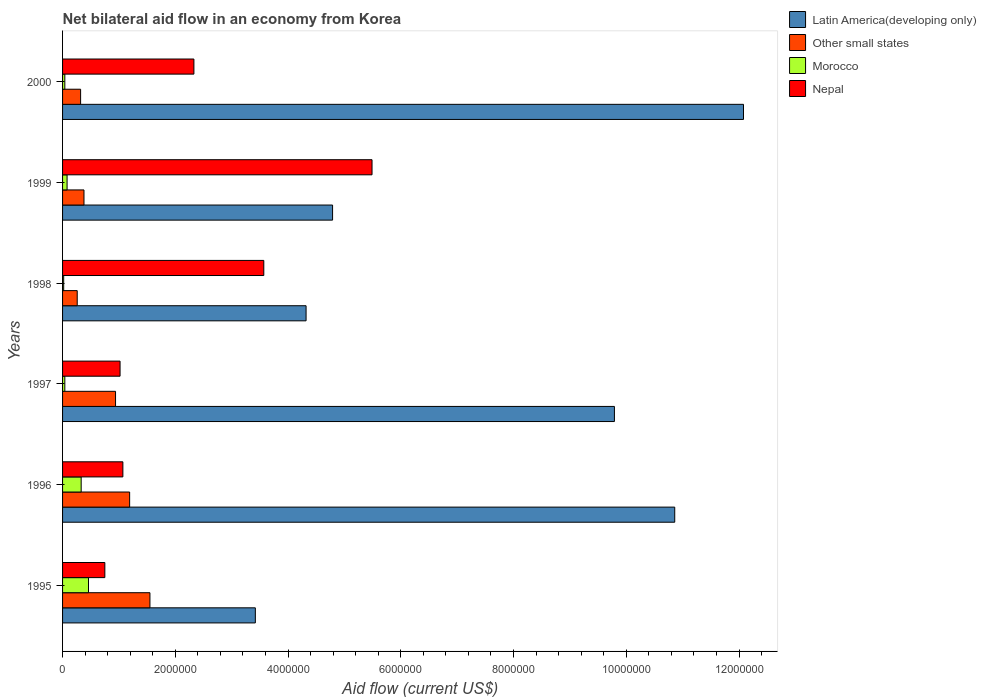Are the number of bars per tick equal to the number of legend labels?
Your answer should be very brief. Yes. How many bars are there on the 3rd tick from the top?
Provide a short and direct response. 4. What is the label of the 2nd group of bars from the top?
Your answer should be very brief. 1999. What is the net bilateral aid flow in Morocco in 1996?
Ensure brevity in your answer.  3.30e+05. Across all years, what is the maximum net bilateral aid flow in Nepal?
Give a very brief answer. 5.49e+06. Across all years, what is the minimum net bilateral aid flow in Other small states?
Your response must be concise. 2.60e+05. In which year was the net bilateral aid flow in Morocco maximum?
Ensure brevity in your answer.  1995. What is the total net bilateral aid flow in Nepal in the graph?
Make the answer very short. 1.42e+07. What is the difference between the net bilateral aid flow in Nepal in 1997 and that in 1999?
Offer a very short reply. -4.47e+06. What is the difference between the net bilateral aid flow in Latin America(developing only) in 1996 and the net bilateral aid flow in Morocco in 1995?
Your answer should be very brief. 1.04e+07. What is the average net bilateral aid flow in Nepal per year?
Keep it short and to the point. 2.37e+06. In the year 1995, what is the difference between the net bilateral aid flow in Morocco and net bilateral aid flow in Other small states?
Provide a short and direct response. -1.09e+06. In how many years, is the net bilateral aid flow in Morocco greater than 800000 US$?
Offer a terse response. 0. Is the net bilateral aid flow in Nepal in 1996 less than that in 1998?
Give a very brief answer. Yes. What is the difference between the highest and the second highest net bilateral aid flow in Latin America(developing only)?
Offer a very short reply. 1.22e+06. What is the difference between the highest and the lowest net bilateral aid flow in Nepal?
Make the answer very short. 4.74e+06. In how many years, is the net bilateral aid flow in Other small states greater than the average net bilateral aid flow in Other small states taken over all years?
Give a very brief answer. 3. What does the 3rd bar from the top in 1999 represents?
Provide a short and direct response. Other small states. What does the 1st bar from the bottom in 1999 represents?
Your answer should be very brief. Latin America(developing only). How many years are there in the graph?
Your answer should be compact. 6. What is the difference between two consecutive major ticks on the X-axis?
Your response must be concise. 2.00e+06. What is the title of the graph?
Give a very brief answer. Net bilateral aid flow in an economy from Korea. Does "Tonga" appear as one of the legend labels in the graph?
Make the answer very short. No. What is the Aid flow (current US$) in Latin America(developing only) in 1995?
Your response must be concise. 3.42e+06. What is the Aid flow (current US$) of Other small states in 1995?
Give a very brief answer. 1.55e+06. What is the Aid flow (current US$) of Nepal in 1995?
Offer a very short reply. 7.50e+05. What is the Aid flow (current US$) in Latin America(developing only) in 1996?
Keep it short and to the point. 1.09e+07. What is the Aid flow (current US$) in Other small states in 1996?
Provide a short and direct response. 1.19e+06. What is the Aid flow (current US$) of Morocco in 1996?
Offer a terse response. 3.30e+05. What is the Aid flow (current US$) of Nepal in 1996?
Keep it short and to the point. 1.07e+06. What is the Aid flow (current US$) of Latin America(developing only) in 1997?
Your response must be concise. 9.79e+06. What is the Aid flow (current US$) of Other small states in 1997?
Provide a short and direct response. 9.40e+05. What is the Aid flow (current US$) in Morocco in 1997?
Your answer should be very brief. 4.00e+04. What is the Aid flow (current US$) in Nepal in 1997?
Ensure brevity in your answer.  1.02e+06. What is the Aid flow (current US$) in Latin America(developing only) in 1998?
Your response must be concise. 4.32e+06. What is the Aid flow (current US$) of Nepal in 1998?
Your answer should be compact. 3.57e+06. What is the Aid flow (current US$) of Latin America(developing only) in 1999?
Your answer should be very brief. 4.79e+06. What is the Aid flow (current US$) in Other small states in 1999?
Give a very brief answer. 3.80e+05. What is the Aid flow (current US$) of Morocco in 1999?
Offer a very short reply. 8.00e+04. What is the Aid flow (current US$) in Nepal in 1999?
Provide a short and direct response. 5.49e+06. What is the Aid flow (current US$) in Latin America(developing only) in 2000?
Provide a succinct answer. 1.21e+07. What is the Aid flow (current US$) in Morocco in 2000?
Your answer should be compact. 4.00e+04. What is the Aid flow (current US$) of Nepal in 2000?
Your answer should be very brief. 2.33e+06. Across all years, what is the maximum Aid flow (current US$) in Latin America(developing only)?
Your answer should be very brief. 1.21e+07. Across all years, what is the maximum Aid flow (current US$) in Other small states?
Make the answer very short. 1.55e+06. Across all years, what is the maximum Aid flow (current US$) in Morocco?
Your answer should be compact. 4.60e+05. Across all years, what is the maximum Aid flow (current US$) in Nepal?
Keep it short and to the point. 5.49e+06. Across all years, what is the minimum Aid flow (current US$) in Latin America(developing only)?
Offer a very short reply. 3.42e+06. Across all years, what is the minimum Aid flow (current US$) in Morocco?
Offer a very short reply. 2.00e+04. Across all years, what is the minimum Aid flow (current US$) of Nepal?
Ensure brevity in your answer.  7.50e+05. What is the total Aid flow (current US$) in Latin America(developing only) in the graph?
Offer a very short reply. 4.53e+07. What is the total Aid flow (current US$) of Other small states in the graph?
Provide a short and direct response. 4.64e+06. What is the total Aid flow (current US$) in Morocco in the graph?
Your answer should be very brief. 9.70e+05. What is the total Aid flow (current US$) in Nepal in the graph?
Keep it short and to the point. 1.42e+07. What is the difference between the Aid flow (current US$) of Latin America(developing only) in 1995 and that in 1996?
Give a very brief answer. -7.44e+06. What is the difference between the Aid flow (current US$) in Other small states in 1995 and that in 1996?
Ensure brevity in your answer.  3.60e+05. What is the difference between the Aid flow (current US$) in Morocco in 1995 and that in 1996?
Keep it short and to the point. 1.30e+05. What is the difference between the Aid flow (current US$) of Nepal in 1995 and that in 1996?
Offer a terse response. -3.20e+05. What is the difference between the Aid flow (current US$) of Latin America(developing only) in 1995 and that in 1997?
Your response must be concise. -6.37e+06. What is the difference between the Aid flow (current US$) of Other small states in 1995 and that in 1997?
Give a very brief answer. 6.10e+05. What is the difference between the Aid flow (current US$) in Nepal in 1995 and that in 1997?
Offer a very short reply. -2.70e+05. What is the difference between the Aid flow (current US$) in Latin America(developing only) in 1995 and that in 1998?
Your answer should be compact. -9.00e+05. What is the difference between the Aid flow (current US$) of Other small states in 1995 and that in 1998?
Keep it short and to the point. 1.29e+06. What is the difference between the Aid flow (current US$) in Morocco in 1995 and that in 1998?
Your answer should be very brief. 4.40e+05. What is the difference between the Aid flow (current US$) in Nepal in 1995 and that in 1998?
Your response must be concise. -2.82e+06. What is the difference between the Aid flow (current US$) of Latin America(developing only) in 1995 and that in 1999?
Your answer should be very brief. -1.37e+06. What is the difference between the Aid flow (current US$) in Other small states in 1995 and that in 1999?
Ensure brevity in your answer.  1.17e+06. What is the difference between the Aid flow (current US$) in Nepal in 1995 and that in 1999?
Your answer should be very brief. -4.74e+06. What is the difference between the Aid flow (current US$) in Latin America(developing only) in 1995 and that in 2000?
Ensure brevity in your answer.  -8.66e+06. What is the difference between the Aid flow (current US$) of Other small states in 1995 and that in 2000?
Your answer should be very brief. 1.23e+06. What is the difference between the Aid flow (current US$) in Morocco in 1995 and that in 2000?
Your answer should be very brief. 4.20e+05. What is the difference between the Aid flow (current US$) of Nepal in 1995 and that in 2000?
Your answer should be compact. -1.58e+06. What is the difference between the Aid flow (current US$) of Latin America(developing only) in 1996 and that in 1997?
Make the answer very short. 1.07e+06. What is the difference between the Aid flow (current US$) of Other small states in 1996 and that in 1997?
Offer a terse response. 2.50e+05. What is the difference between the Aid flow (current US$) of Latin America(developing only) in 1996 and that in 1998?
Offer a very short reply. 6.54e+06. What is the difference between the Aid flow (current US$) in Other small states in 1996 and that in 1998?
Provide a succinct answer. 9.30e+05. What is the difference between the Aid flow (current US$) in Nepal in 1996 and that in 1998?
Your answer should be compact. -2.50e+06. What is the difference between the Aid flow (current US$) in Latin America(developing only) in 1996 and that in 1999?
Your answer should be very brief. 6.07e+06. What is the difference between the Aid flow (current US$) of Other small states in 1996 and that in 1999?
Provide a succinct answer. 8.10e+05. What is the difference between the Aid flow (current US$) in Nepal in 1996 and that in 1999?
Your answer should be compact. -4.42e+06. What is the difference between the Aid flow (current US$) in Latin America(developing only) in 1996 and that in 2000?
Give a very brief answer. -1.22e+06. What is the difference between the Aid flow (current US$) of Other small states in 1996 and that in 2000?
Your answer should be compact. 8.70e+05. What is the difference between the Aid flow (current US$) in Morocco in 1996 and that in 2000?
Provide a succinct answer. 2.90e+05. What is the difference between the Aid flow (current US$) in Nepal in 1996 and that in 2000?
Provide a short and direct response. -1.26e+06. What is the difference between the Aid flow (current US$) in Latin America(developing only) in 1997 and that in 1998?
Your response must be concise. 5.47e+06. What is the difference between the Aid flow (current US$) of Other small states in 1997 and that in 1998?
Your answer should be compact. 6.80e+05. What is the difference between the Aid flow (current US$) in Nepal in 1997 and that in 1998?
Your answer should be very brief. -2.55e+06. What is the difference between the Aid flow (current US$) in Other small states in 1997 and that in 1999?
Offer a terse response. 5.60e+05. What is the difference between the Aid flow (current US$) of Nepal in 1997 and that in 1999?
Give a very brief answer. -4.47e+06. What is the difference between the Aid flow (current US$) in Latin America(developing only) in 1997 and that in 2000?
Provide a short and direct response. -2.29e+06. What is the difference between the Aid flow (current US$) of Other small states in 1997 and that in 2000?
Your answer should be compact. 6.20e+05. What is the difference between the Aid flow (current US$) in Nepal in 1997 and that in 2000?
Keep it short and to the point. -1.31e+06. What is the difference between the Aid flow (current US$) in Latin America(developing only) in 1998 and that in 1999?
Your response must be concise. -4.70e+05. What is the difference between the Aid flow (current US$) in Other small states in 1998 and that in 1999?
Your answer should be very brief. -1.20e+05. What is the difference between the Aid flow (current US$) of Morocco in 1998 and that in 1999?
Make the answer very short. -6.00e+04. What is the difference between the Aid flow (current US$) of Nepal in 1998 and that in 1999?
Give a very brief answer. -1.92e+06. What is the difference between the Aid flow (current US$) in Latin America(developing only) in 1998 and that in 2000?
Offer a terse response. -7.76e+06. What is the difference between the Aid flow (current US$) in Other small states in 1998 and that in 2000?
Your answer should be compact. -6.00e+04. What is the difference between the Aid flow (current US$) in Morocco in 1998 and that in 2000?
Keep it short and to the point. -2.00e+04. What is the difference between the Aid flow (current US$) in Nepal in 1998 and that in 2000?
Your answer should be very brief. 1.24e+06. What is the difference between the Aid flow (current US$) in Latin America(developing only) in 1999 and that in 2000?
Offer a terse response. -7.29e+06. What is the difference between the Aid flow (current US$) in Other small states in 1999 and that in 2000?
Give a very brief answer. 6.00e+04. What is the difference between the Aid flow (current US$) of Nepal in 1999 and that in 2000?
Offer a terse response. 3.16e+06. What is the difference between the Aid flow (current US$) in Latin America(developing only) in 1995 and the Aid flow (current US$) in Other small states in 1996?
Provide a short and direct response. 2.23e+06. What is the difference between the Aid flow (current US$) of Latin America(developing only) in 1995 and the Aid flow (current US$) of Morocco in 1996?
Ensure brevity in your answer.  3.09e+06. What is the difference between the Aid flow (current US$) of Latin America(developing only) in 1995 and the Aid flow (current US$) of Nepal in 1996?
Your answer should be very brief. 2.35e+06. What is the difference between the Aid flow (current US$) in Other small states in 1995 and the Aid flow (current US$) in Morocco in 1996?
Make the answer very short. 1.22e+06. What is the difference between the Aid flow (current US$) of Morocco in 1995 and the Aid flow (current US$) of Nepal in 1996?
Give a very brief answer. -6.10e+05. What is the difference between the Aid flow (current US$) in Latin America(developing only) in 1995 and the Aid flow (current US$) in Other small states in 1997?
Provide a short and direct response. 2.48e+06. What is the difference between the Aid flow (current US$) in Latin America(developing only) in 1995 and the Aid flow (current US$) in Morocco in 1997?
Offer a very short reply. 3.38e+06. What is the difference between the Aid flow (current US$) in Latin America(developing only) in 1995 and the Aid flow (current US$) in Nepal in 1997?
Offer a terse response. 2.40e+06. What is the difference between the Aid flow (current US$) of Other small states in 1995 and the Aid flow (current US$) of Morocco in 1997?
Your answer should be very brief. 1.51e+06. What is the difference between the Aid flow (current US$) of Other small states in 1995 and the Aid flow (current US$) of Nepal in 1997?
Offer a very short reply. 5.30e+05. What is the difference between the Aid flow (current US$) of Morocco in 1995 and the Aid flow (current US$) of Nepal in 1997?
Provide a succinct answer. -5.60e+05. What is the difference between the Aid flow (current US$) of Latin America(developing only) in 1995 and the Aid flow (current US$) of Other small states in 1998?
Provide a succinct answer. 3.16e+06. What is the difference between the Aid flow (current US$) in Latin America(developing only) in 1995 and the Aid flow (current US$) in Morocco in 1998?
Offer a terse response. 3.40e+06. What is the difference between the Aid flow (current US$) in Other small states in 1995 and the Aid flow (current US$) in Morocco in 1998?
Make the answer very short. 1.53e+06. What is the difference between the Aid flow (current US$) of Other small states in 1995 and the Aid flow (current US$) of Nepal in 1998?
Make the answer very short. -2.02e+06. What is the difference between the Aid flow (current US$) in Morocco in 1995 and the Aid flow (current US$) in Nepal in 1998?
Give a very brief answer. -3.11e+06. What is the difference between the Aid flow (current US$) in Latin America(developing only) in 1995 and the Aid flow (current US$) in Other small states in 1999?
Give a very brief answer. 3.04e+06. What is the difference between the Aid flow (current US$) of Latin America(developing only) in 1995 and the Aid flow (current US$) of Morocco in 1999?
Provide a short and direct response. 3.34e+06. What is the difference between the Aid flow (current US$) of Latin America(developing only) in 1995 and the Aid flow (current US$) of Nepal in 1999?
Make the answer very short. -2.07e+06. What is the difference between the Aid flow (current US$) of Other small states in 1995 and the Aid flow (current US$) of Morocco in 1999?
Provide a succinct answer. 1.47e+06. What is the difference between the Aid flow (current US$) of Other small states in 1995 and the Aid flow (current US$) of Nepal in 1999?
Offer a terse response. -3.94e+06. What is the difference between the Aid flow (current US$) in Morocco in 1995 and the Aid flow (current US$) in Nepal in 1999?
Ensure brevity in your answer.  -5.03e+06. What is the difference between the Aid flow (current US$) of Latin America(developing only) in 1995 and the Aid flow (current US$) of Other small states in 2000?
Ensure brevity in your answer.  3.10e+06. What is the difference between the Aid flow (current US$) in Latin America(developing only) in 1995 and the Aid flow (current US$) in Morocco in 2000?
Ensure brevity in your answer.  3.38e+06. What is the difference between the Aid flow (current US$) in Latin America(developing only) in 1995 and the Aid flow (current US$) in Nepal in 2000?
Your answer should be very brief. 1.09e+06. What is the difference between the Aid flow (current US$) of Other small states in 1995 and the Aid flow (current US$) of Morocco in 2000?
Keep it short and to the point. 1.51e+06. What is the difference between the Aid flow (current US$) of Other small states in 1995 and the Aid flow (current US$) of Nepal in 2000?
Your response must be concise. -7.80e+05. What is the difference between the Aid flow (current US$) in Morocco in 1995 and the Aid flow (current US$) in Nepal in 2000?
Your answer should be very brief. -1.87e+06. What is the difference between the Aid flow (current US$) in Latin America(developing only) in 1996 and the Aid flow (current US$) in Other small states in 1997?
Offer a very short reply. 9.92e+06. What is the difference between the Aid flow (current US$) of Latin America(developing only) in 1996 and the Aid flow (current US$) of Morocco in 1997?
Your answer should be very brief. 1.08e+07. What is the difference between the Aid flow (current US$) in Latin America(developing only) in 1996 and the Aid flow (current US$) in Nepal in 1997?
Ensure brevity in your answer.  9.84e+06. What is the difference between the Aid flow (current US$) in Other small states in 1996 and the Aid flow (current US$) in Morocco in 1997?
Provide a succinct answer. 1.15e+06. What is the difference between the Aid flow (current US$) in Other small states in 1996 and the Aid flow (current US$) in Nepal in 1997?
Ensure brevity in your answer.  1.70e+05. What is the difference between the Aid flow (current US$) of Morocco in 1996 and the Aid flow (current US$) of Nepal in 1997?
Make the answer very short. -6.90e+05. What is the difference between the Aid flow (current US$) of Latin America(developing only) in 1996 and the Aid flow (current US$) of Other small states in 1998?
Keep it short and to the point. 1.06e+07. What is the difference between the Aid flow (current US$) in Latin America(developing only) in 1996 and the Aid flow (current US$) in Morocco in 1998?
Ensure brevity in your answer.  1.08e+07. What is the difference between the Aid flow (current US$) of Latin America(developing only) in 1996 and the Aid flow (current US$) of Nepal in 1998?
Your response must be concise. 7.29e+06. What is the difference between the Aid flow (current US$) of Other small states in 1996 and the Aid flow (current US$) of Morocco in 1998?
Your answer should be very brief. 1.17e+06. What is the difference between the Aid flow (current US$) in Other small states in 1996 and the Aid flow (current US$) in Nepal in 1998?
Make the answer very short. -2.38e+06. What is the difference between the Aid flow (current US$) in Morocco in 1996 and the Aid flow (current US$) in Nepal in 1998?
Offer a terse response. -3.24e+06. What is the difference between the Aid flow (current US$) in Latin America(developing only) in 1996 and the Aid flow (current US$) in Other small states in 1999?
Provide a short and direct response. 1.05e+07. What is the difference between the Aid flow (current US$) in Latin America(developing only) in 1996 and the Aid flow (current US$) in Morocco in 1999?
Keep it short and to the point. 1.08e+07. What is the difference between the Aid flow (current US$) of Latin America(developing only) in 1996 and the Aid flow (current US$) of Nepal in 1999?
Provide a succinct answer. 5.37e+06. What is the difference between the Aid flow (current US$) in Other small states in 1996 and the Aid flow (current US$) in Morocco in 1999?
Offer a terse response. 1.11e+06. What is the difference between the Aid flow (current US$) in Other small states in 1996 and the Aid flow (current US$) in Nepal in 1999?
Your answer should be compact. -4.30e+06. What is the difference between the Aid flow (current US$) in Morocco in 1996 and the Aid flow (current US$) in Nepal in 1999?
Your response must be concise. -5.16e+06. What is the difference between the Aid flow (current US$) in Latin America(developing only) in 1996 and the Aid flow (current US$) in Other small states in 2000?
Your answer should be very brief. 1.05e+07. What is the difference between the Aid flow (current US$) in Latin America(developing only) in 1996 and the Aid flow (current US$) in Morocco in 2000?
Offer a very short reply. 1.08e+07. What is the difference between the Aid flow (current US$) of Latin America(developing only) in 1996 and the Aid flow (current US$) of Nepal in 2000?
Make the answer very short. 8.53e+06. What is the difference between the Aid flow (current US$) of Other small states in 1996 and the Aid flow (current US$) of Morocco in 2000?
Your response must be concise. 1.15e+06. What is the difference between the Aid flow (current US$) in Other small states in 1996 and the Aid flow (current US$) in Nepal in 2000?
Offer a terse response. -1.14e+06. What is the difference between the Aid flow (current US$) of Latin America(developing only) in 1997 and the Aid flow (current US$) of Other small states in 1998?
Provide a succinct answer. 9.53e+06. What is the difference between the Aid flow (current US$) of Latin America(developing only) in 1997 and the Aid flow (current US$) of Morocco in 1998?
Your response must be concise. 9.77e+06. What is the difference between the Aid flow (current US$) of Latin America(developing only) in 1997 and the Aid flow (current US$) of Nepal in 1998?
Offer a terse response. 6.22e+06. What is the difference between the Aid flow (current US$) in Other small states in 1997 and the Aid flow (current US$) in Morocco in 1998?
Your answer should be compact. 9.20e+05. What is the difference between the Aid flow (current US$) in Other small states in 1997 and the Aid flow (current US$) in Nepal in 1998?
Offer a terse response. -2.63e+06. What is the difference between the Aid flow (current US$) in Morocco in 1997 and the Aid flow (current US$) in Nepal in 1998?
Offer a very short reply. -3.53e+06. What is the difference between the Aid flow (current US$) of Latin America(developing only) in 1997 and the Aid flow (current US$) of Other small states in 1999?
Ensure brevity in your answer.  9.41e+06. What is the difference between the Aid flow (current US$) in Latin America(developing only) in 1997 and the Aid flow (current US$) in Morocco in 1999?
Give a very brief answer. 9.71e+06. What is the difference between the Aid flow (current US$) in Latin America(developing only) in 1997 and the Aid flow (current US$) in Nepal in 1999?
Offer a terse response. 4.30e+06. What is the difference between the Aid flow (current US$) in Other small states in 1997 and the Aid flow (current US$) in Morocco in 1999?
Make the answer very short. 8.60e+05. What is the difference between the Aid flow (current US$) in Other small states in 1997 and the Aid flow (current US$) in Nepal in 1999?
Your response must be concise. -4.55e+06. What is the difference between the Aid flow (current US$) in Morocco in 1997 and the Aid flow (current US$) in Nepal in 1999?
Ensure brevity in your answer.  -5.45e+06. What is the difference between the Aid flow (current US$) in Latin America(developing only) in 1997 and the Aid flow (current US$) in Other small states in 2000?
Your response must be concise. 9.47e+06. What is the difference between the Aid flow (current US$) of Latin America(developing only) in 1997 and the Aid flow (current US$) of Morocco in 2000?
Offer a terse response. 9.75e+06. What is the difference between the Aid flow (current US$) of Latin America(developing only) in 1997 and the Aid flow (current US$) of Nepal in 2000?
Offer a terse response. 7.46e+06. What is the difference between the Aid flow (current US$) of Other small states in 1997 and the Aid flow (current US$) of Morocco in 2000?
Your answer should be compact. 9.00e+05. What is the difference between the Aid flow (current US$) of Other small states in 1997 and the Aid flow (current US$) of Nepal in 2000?
Your response must be concise. -1.39e+06. What is the difference between the Aid flow (current US$) in Morocco in 1997 and the Aid flow (current US$) in Nepal in 2000?
Offer a very short reply. -2.29e+06. What is the difference between the Aid flow (current US$) in Latin America(developing only) in 1998 and the Aid flow (current US$) in Other small states in 1999?
Your response must be concise. 3.94e+06. What is the difference between the Aid flow (current US$) in Latin America(developing only) in 1998 and the Aid flow (current US$) in Morocco in 1999?
Give a very brief answer. 4.24e+06. What is the difference between the Aid flow (current US$) of Latin America(developing only) in 1998 and the Aid flow (current US$) of Nepal in 1999?
Keep it short and to the point. -1.17e+06. What is the difference between the Aid flow (current US$) in Other small states in 1998 and the Aid flow (current US$) in Nepal in 1999?
Give a very brief answer. -5.23e+06. What is the difference between the Aid flow (current US$) of Morocco in 1998 and the Aid flow (current US$) of Nepal in 1999?
Give a very brief answer. -5.47e+06. What is the difference between the Aid flow (current US$) of Latin America(developing only) in 1998 and the Aid flow (current US$) of Other small states in 2000?
Ensure brevity in your answer.  4.00e+06. What is the difference between the Aid flow (current US$) in Latin America(developing only) in 1998 and the Aid flow (current US$) in Morocco in 2000?
Offer a very short reply. 4.28e+06. What is the difference between the Aid flow (current US$) of Latin America(developing only) in 1998 and the Aid flow (current US$) of Nepal in 2000?
Your answer should be very brief. 1.99e+06. What is the difference between the Aid flow (current US$) of Other small states in 1998 and the Aid flow (current US$) of Nepal in 2000?
Your answer should be compact. -2.07e+06. What is the difference between the Aid flow (current US$) of Morocco in 1998 and the Aid flow (current US$) of Nepal in 2000?
Your answer should be compact. -2.31e+06. What is the difference between the Aid flow (current US$) in Latin America(developing only) in 1999 and the Aid flow (current US$) in Other small states in 2000?
Offer a terse response. 4.47e+06. What is the difference between the Aid flow (current US$) in Latin America(developing only) in 1999 and the Aid flow (current US$) in Morocco in 2000?
Keep it short and to the point. 4.75e+06. What is the difference between the Aid flow (current US$) of Latin America(developing only) in 1999 and the Aid flow (current US$) of Nepal in 2000?
Offer a very short reply. 2.46e+06. What is the difference between the Aid flow (current US$) in Other small states in 1999 and the Aid flow (current US$) in Nepal in 2000?
Your answer should be very brief. -1.95e+06. What is the difference between the Aid flow (current US$) in Morocco in 1999 and the Aid flow (current US$) in Nepal in 2000?
Make the answer very short. -2.25e+06. What is the average Aid flow (current US$) of Latin America(developing only) per year?
Provide a short and direct response. 7.54e+06. What is the average Aid flow (current US$) in Other small states per year?
Provide a succinct answer. 7.73e+05. What is the average Aid flow (current US$) of Morocco per year?
Keep it short and to the point. 1.62e+05. What is the average Aid flow (current US$) in Nepal per year?
Offer a terse response. 2.37e+06. In the year 1995, what is the difference between the Aid flow (current US$) of Latin America(developing only) and Aid flow (current US$) of Other small states?
Make the answer very short. 1.87e+06. In the year 1995, what is the difference between the Aid flow (current US$) in Latin America(developing only) and Aid flow (current US$) in Morocco?
Provide a short and direct response. 2.96e+06. In the year 1995, what is the difference between the Aid flow (current US$) in Latin America(developing only) and Aid flow (current US$) in Nepal?
Offer a very short reply. 2.67e+06. In the year 1995, what is the difference between the Aid flow (current US$) of Other small states and Aid flow (current US$) of Morocco?
Make the answer very short. 1.09e+06. In the year 1995, what is the difference between the Aid flow (current US$) of Other small states and Aid flow (current US$) of Nepal?
Offer a terse response. 8.00e+05. In the year 1995, what is the difference between the Aid flow (current US$) in Morocco and Aid flow (current US$) in Nepal?
Give a very brief answer. -2.90e+05. In the year 1996, what is the difference between the Aid flow (current US$) in Latin America(developing only) and Aid flow (current US$) in Other small states?
Make the answer very short. 9.67e+06. In the year 1996, what is the difference between the Aid flow (current US$) in Latin America(developing only) and Aid flow (current US$) in Morocco?
Give a very brief answer. 1.05e+07. In the year 1996, what is the difference between the Aid flow (current US$) of Latin America(developing only) and Aid flow (current US$) of Nepal?
Offer a terse response. 9.79e+06. In the year 1996, what is the difference between the Aid flow (current US$) in Other small states and Aid flow (current US$) in Morocco?
Offer a very short reply. 8.60e+05. In the year 1996, what is the difference between the Aid flow (current US$) in Other small states and Aid flow (current US$) in Nepal?
Provide a succinct answer. 1.20e+05. In the year 1996, what is the difference between the Aid flow (current US$) of Morocco and Aid flow (current US$) of Nepal?
Provide a succinct answer. -7.40e+05. In the year 1997, what is the difference between the Aid flow (current US$) in Latin America(developing only) and Aid flow (current US$) in Other small states?
Offer a terse response. 8.85e+06. In the year 1997, what is the difference between the Aid flow (current US$) of Latin America(developing only) and Aid flow (current US$) of Morocco?
Your answer should be compact. 9.75e+06. In the year 1997, what is the difference between the Aid flow (current US$) of Latin America(developing only) and Aid flow (current US$) of Nepal?
Provide a short and direct response. 8.77e+06. In the year 1997, what is the difference between the Aid flow (current US$) in Morocco and Aid flow (current US$) in Nepal?
Your response must be concise. -9.80e+05. In the year 1998, what is the difference between the Aid flow (current US$) of Latin America(developing only) and Aid flow (current US$) of Other small states?
Your response must be concise. 4.06e+06. In the year 1998, what is the difference between the Aid flow (current US$) in Latin America(developing only) and Aid flow (current US$) in Morocco?
Ensure brevity in your answer.  4.30e+06. In the year 1998, what is the difference between the Aid flow (current US$) of Latin America(developing only) and Aid flow (current US$) of Nepal?
Give a very brief answer. 7.50e+05. In the year 1998, what is the difference between the Aid flow (current US$) of Other small states and Aid flow (current US$) of Nepal?
Your answer should be compact. -3.31e+06. In the year 1998, what is the difference between the Aid flow (current US$) of Morocco and Aid flow (current US$) of Nepal?
Give a very brief answer. -3.55e+06. In the year 1999, what is the difference between the Aid flow (current US$) in Latin America(developing only) and Aid flow (current US$) in Other small states?
Ensure brevity in your answer.  4.41e+06. In the year 1999, what is the difference between the Aid flow (current US$) of Latin America(developing only) and Aid flow (current US$) of Morocco?
Provide a short and direct response. 4.71e+06. In the year 1999, what is the difference between the Aid flow (current US$) of Latin America(developing only) and Aid flow (current US$) of Nepal?
Make the answer very short. -7.00e+05. In the year 1999, what is the difference between the Aid flow (current US$) of Other small states and Aid flow (current US$) of Nepal?
Provide a short and direct response. -5.11e+06. In the year 1999, what is the difference between the Aid flow (current US$) of Morocco and Aid flow (current US$) of Nepal?
Provide a succinct answer. -5.41e+06. In the year 2000, what is the difference between the Aid flow (current US$) in Latin America(developing only) and Aid flow (current US$) in Other small states?
Keep it short and to the point. 1.18e+07. In the year 2000, what is the difference between the Aid flow (current US$) of Latin America(developing only) and Aid flow (current US$) of Morocco?
Make the answer very short. 1.20e+07. In the year 2000, what is the difference between the Aid flow (current US$) in Latin America(developing only) and Aid flow (current US$) in Nepal?
Offer a very short reply. 9.75e+06. In the year 2000, what is the difference between the Aid flow (current US$) in Other small states and Aid flow (current US$) in Morocco?
Keep it short and to the point. 2.80e+05. In the year 2000, what is the difference between the Aid flow (current US$) in Other small states and Aid flow (current US$) in Nepal?
Offer a very short reply. -2.01e+06. In the year 2000, what is the difference between the Aid flow (current US$) in Morocco and Aid flow (current US$) in Nepal?
Keep it short and to the point. -2.29e+06. What is the ratio of the Aid flow (current US$) of Latin America(developing only) in 1995 to that in 1996?
Offer a very short reply. 0.31. What is the ratio of the Aid flow (current US$) in Other small states in 1995 to that in 1996?
Provide a succinct answer. 1.3. What is the ratio of the Aid flow (current US$) in Morocco in 1995 to that in 1996?
Offer a terse response. 1.39. What is the ratio of the Aid flow (current US$) of Nepal in 1995 to that in 1996?
Make the answer very short. 0.7. What is the ratio of the Aid flow (current US$) of Latin America(developing only) in 1995 to that in 1997?
Offer a very short reply. 0.35. What is the ratio of the Aid flow (current US$) of Other small states in 1995 to that in 1997?
Your answer should be compact. 1.65. What is the ratio of the Aid flow (current US$) of Morocco in 1995 to that in 1997?
Keep it short and to the point. 11.5. What is the ratio of the Aid flow (current US$) of Nepal in 1995 to that in 1997?
Make the answer very short. 0.74. What is the ratio of the Aid flow (current US$) of Latin America(developing only) in 1995 to that in 1998?
Offer a terse response. 0.79. What is the ratio of the Aid flow (current US$) in Other small states in 1995 to that in 1998?
Keep it short and to the point. 5.96. What is the ratio of the Aid flow (current US$) in Nepal in 1995 to that in 1998?
Keep it short and to the point. 0.21. What is the ratio of the Aid flow (current US$) of Latin America(developing only) in 1995 to that in 1999?
Your response must be concise. 0.71. What is the ratio of the Aid flow (current US$) in Other small states in 1995 to that in 1999?
Provide a short and direct response. 4.08. What is the ratio of the Aid flow (current US$) of Morocco in 1995 to that in 1999?
Offer a very short reply. 5.75. What is the ratio of the Aid flow (current US$) of Nepal in 1995 to that in 1999?
Give a very brief answer. 0.14. What is the ratio of the Aid flow (current US$) in Latin America(developing only) in 1995 to that in 2000?
Keep it short and to the point. 0.28. What is the ratio of the Aid flow (current US$) in Other small states in 1995 to that in 2000?
Offer a terse response. 4.84. What is the ratio of the Aid flow (current US$) in Nepal in 1995 to that in 2000?
Your answer should be compact. 0.32. What is the ratio of the Aid flow (current US$) of Latin America(developing only) in 1996 to that in 1997?
Your response must be concise. 1.11. What is the ratio of the Aid flow (current US$) of Other small states in 1996 to that in 1997?
Your response must be concise. 1.27. What is the ratio of the Aid flow (current US$) of Morocco in 1996 to that in 1997?
Your answer should be very brief. 8.25. What is the ratio of the Aid flow (current US$) of Nepal in 1996 to that in 1997?
Give a very brief answer. 1.05. What is the ratio of the Aid flow (current US$) in Latin America(developing only) in 1996 to that in 1998?
Keep it short and to the point. 2.51. What is the ratio of the Aid flow (current US$) in Other small states in 1996 to that in 1998?
Give a very brief answer. 4.58. What is the ratio of the Aid flow (current US$) of Morocco in 1996 to that in 1998?
Ensure brevity in your answer.  16.5. What is the ratio of the Aid flow (current US$) of Nepal in 1996 to that in 1998?
Your answer should be compact. 0.3. What is the ratio of the Aid flow (current US$) of Latin America(developing only) in 1996 to that in 1999?
Your response must be concise. 2.27. What is the ratio of the Aid flow (current US$) in Other small states in 1996 to that in 1999?
Offer a terse response. 3.13. What is the ratio of the Aid flow (current US$) in Morocco in 1996 to that in 1999?
Your answer should be very brief. 4.12. What is the ratio of the Aid flow (current US$) of Nepal in 1996 to that in 1999?
Provide a succinct answer. 0.19. What is the ratio of the Aid flow (current US$) of Latin America(developing only) in 1996 to that in 2000?
Give a very brief answer. 0.9. What is the ratio of the Aid flow (current US$) in Other small states in 1996 to that in 2000?
Your answer should be very brief. 3.72. What is the ratio of the Aid flow (current US$) in Morocco in 1996 to that in 2000?
Provide a succinct answer. 8.25. What is the ratio of the Aid flow (current US$) in Nepal in 1996 to that in 2000?
Make the answer very short. 0.46. What is the ratio of the Aid flow (current US$) of Latin America(developing only) in 1997 to that in 1998?
Your answer should be compact. 2.27. What is the ratio of the Aid flow (current US$) of Other small states in 1997 to that in 1998?
Offer a terse response. 3.62. What is the ratio of the Aid flow (current US$) of Nepal in 1997 to that in 1998?
Your answer should be compact. 0.29. What is the ratio of the Aid flow (current US$) in Latin America(developing only) in 1997 to that in 1999?
Your answer should be very brief. 2.04. What is the ratio of the Aid flow (current US$) in Other small states in 1997 to that in 1999?
Ensure brevity in your answer.  2.47. What is the ratio of the Aid flow (current US$) in Morocco in 1997 to that in 1999?
Provide a succinct answer. 0.5. What is the ratio of the Aid flow (current US$) of Nepal in 1997 to that in 1999?
Keep it short and to the point. 0.19. What is the ratio of the Aid flow (current US$) of Latin America(developing only) in 1997 to that in 2000?
Offer a very short reply. 0.81. What is the ratio of the Aid flow (current US$) of Other small states in 1997 to that in 2000?
Your response must be concise. 2.94. What is the ratio of the Aid flow (current US$) of Morocco in 1997 to that in 2000?
Your answer should be compact. 1. What is the ratio of the Aid flow (current US$) of Nepal in 1997 to that in 2000?
Make the answer very short. 0.44. What is the ratio of the Aid flow (current US$) of Latin America(developing only) in 1998 to that in 1999?
Ensure brevity in your answer.  0.9. What is the ratio of the Aid flow (current US$) in Other small states in 1998 to that in 1999?
Give a very brief answer. 0.68. What is the ratio of the Aid flow (current US$) of Morocco in 1998 to that in 1999?
Make the answer very short. 0.25. What is the ratio of the Aid flow (current US$) of Nepal in 1998 to that in 1999?
Your answer should be compact. 0.65. What is the ratio of the Aid flow (current US$) in Latin America(developing only) in 1998 to that in 2000?
Provide a succinct answer. 0.36. What is the ratio of the Aid flow (current US$) in Other small states in 1998 to that in 2000?
Provide a short and direct response. 0.81. What is the ratio of the Aid flow (current US$) in Nepal in 1998 to that in 2000?
Ensure brevity in your answer.  1.53. What is the ratio of the Aid flow (current US$) in Latin America(developing only) in 1999 to that in 2000?
Offer a very short reply. 0.4. What is the ratio of the Aid flow (current US$) of Other small states in 1999 to that in 2000?
Keep it short and to the point. 1.19. What is the ratio of the Aid flow (current US$) of Nepal in 1999 to that in 2000?
Make the answer very short. 2.36. What is the difference between the highest and the second highest Aid flow (current US$) in Latin America(developing only)?
Your answer should be compact. 1.22e+06. What is the difference between the highest and the second highest Aid flow (current US$) of Morocco?
Your answer should be very brief. 1.30e+05. What is the difference between the highest and the second highest Aid flow (current US$) of Nepal?
Offer a terse response. 1.92e+06. What is the difference between the highest and the lowest Aid flow (current US$) in Latin America(developing only)?
Your response must be concise. 8.66e+06. What is the difference between the highest and the lowest Aid flow (current US$) in Other small states?
Your answer should be very brief. 1.29e+06. What is the difference between the highest and the lowest Aid flow (current US$) of Morocco?
Give a very brief answer. 4.40e+05. What is the difference between the highest and the lowest Aid flow (current US$) of Nepal?
Provide a succinct answer. 4.74e+06. 